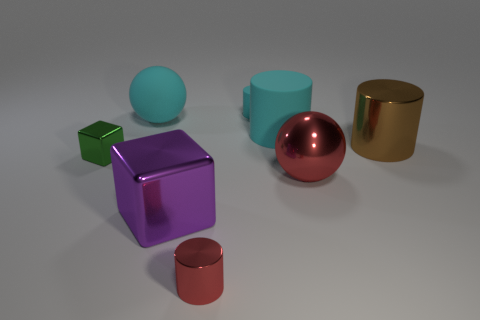Subtract all yellow spheres. Subtract all red cubes. How many spheres are left? 2 Add 1 large cyan rubber balls. How many objects exist? 9 Subtract all blocks. How many objects are left? 6 Subtract 0 yellow cylinders. How many objects are left? 8 Subtract all large purple metallic things. Subtract all big cubes. How many objects are left? 6 Add 8 tiny green metal objects. How many tiny green metal objects are left? 9 Add 1 big metallic blocks. How many big metallic blocks exist? 2 